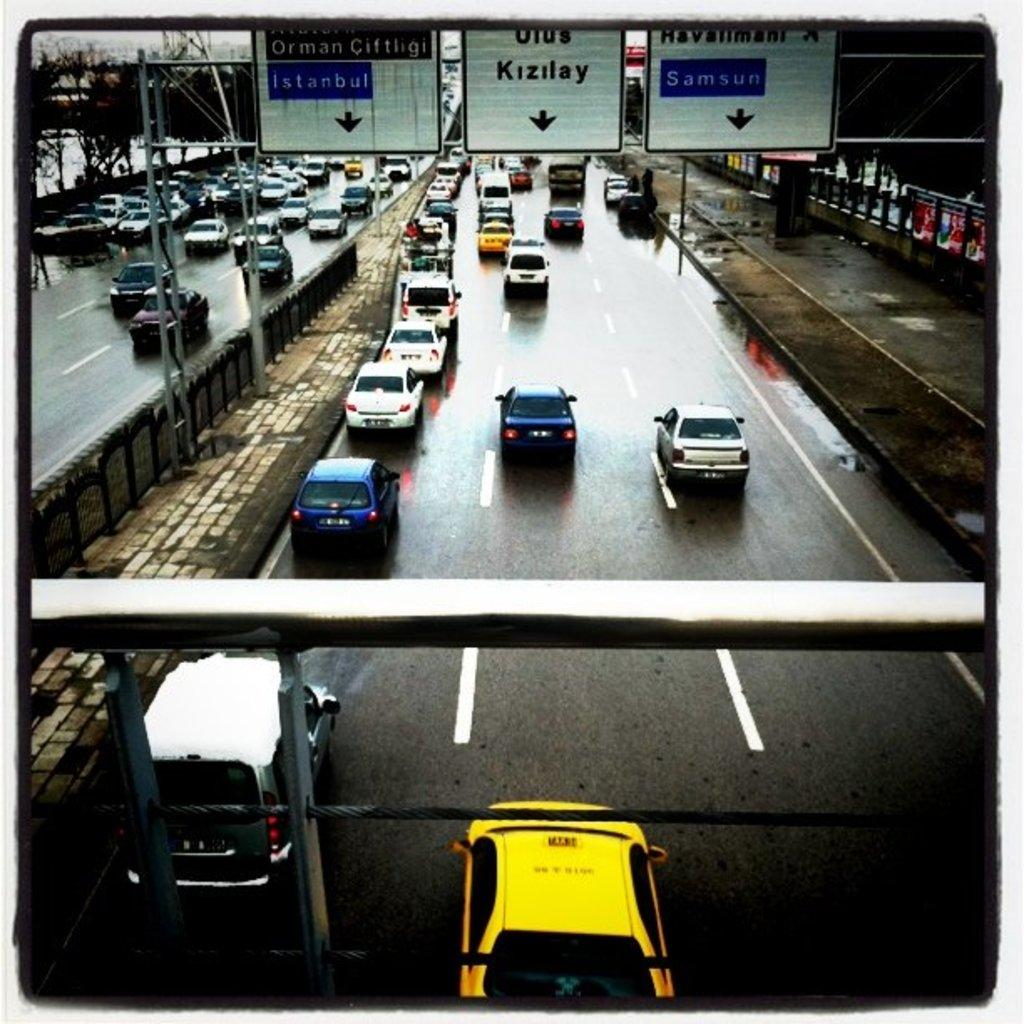<image>
Share a concise interpretation of the image provided. overhead highway signs directing to Istanbul, Kizilay and Samsun 